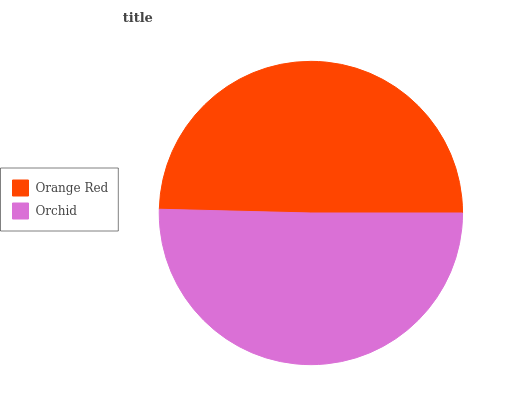Is Orange Red the minimum?
Answer yes or no. Yes. Is Orchid the maximum?
Answer yes or no. Yes. Is Orchid the minimum?
Answer yes or no. No. Is Orchid greater than Orange Red?
Answer yes or no. Yes. Is Orange Red less than Orchid?
Answer yes or no. Yes. Is Orange Red greater than Orchid?
Answer yes or no. No. Is Orchid less than Orange Red?
Answer yes or no. No. Is Orchid the high median?
Answer yes or no. Yes. Is Orange Red the low median?
Answer yes or no. Yes. Is Orange Red the high median?
Answer yes or no. No. Is Orchid the low median?
Answer yes or no. No. 